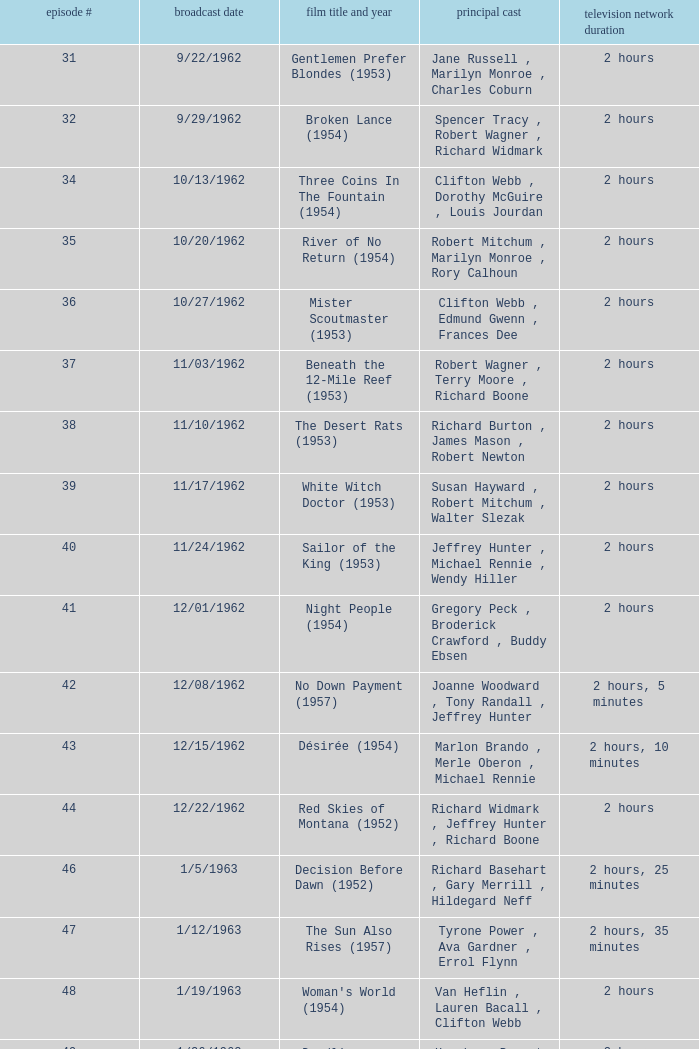Who was the cast on the 3/23/1963 episode? Dana Wynter , Mel Ferrer , Theodore Bikel. Could you parse the entire table? {'header': ['episode #', 'broadcast date', 'film title and year', 'principal cast', 'television network duration'], 'rows': [['31', '9/22/1962', 'Gentlemen Prefer Blondes (1953)', 'Jane Russell , Marilyn Monroe , Charles Coburn', '2 hours'], ['32', '9/29/1962', 'Broken Lance (1954)', 'Spencer Tracy , Robert Wagner , Richard Widmark', '2 hours'], ['34', '10/13/1962', 'Three Coins In The Fountain (1954)', 'Clifton Webb , Dorothy McGuire , Louis Jourdan', '2 hours'], ['35', '10/20/1962', 'River of No Return (1954)', 'Robert Mitchum , Marilyn Monroe , Rory Calhoun', '2 hours'], ['36', '10/27/1962', 'Mister Scoutmaster (1953)', 'Clifton Webb , Edmund Gwenn , Frances Dee', '2 hours'], ['37', '11/03/1962', 'Beneath the 12-Mile Reef (1953)', 'Robert Wagner , Terry Moore , Richard Boone', '2 hours'], ['38', '11/10/1962', 'The Desert Rats (1953)', 'Richard Burton , James Mason , Robert Newton', '2 hours'], ['39', '11/17/1962', 'White Witch Doctor (1953)', 'Susan Hayward , Robert Mitchum , Walter Slezak', '2 hours'], ['40', '11/24/1962', 'Sailor of the King (1953)', 'Jeffrey Hunter , Michael Rennie , Wendy Hiller', '2 hours'], ['41', '12/01/1962', 'Night People (1954)', 'Gregory Peck , Broderick Crawford , Buddy Ebsen', '2 hours'], ['42', '12/08/1962', 'No Down Payment (1957)', 'Joanne Woodward , Tony Randall , Jeffrey Hunter', '2 hours, 5 minutes'], ['43', '12/15/1962', 'Désirée (1954)', 'Marlon Brando , Merle Oberon , Michael Rennie', '2 hours, 10 minutes'], ['44', '12/22/1962', 'Red Skies of Montana (1952)', 'Richard Widmark , Jeffrey Hunter , Richard Boone', '2 hours'], ['46', '1/5/1963', 'Decision Before Dawn (1952)', 'Richard Basehart , Gary Merrill , Hildegard Neff', '2 hours, 25 minutes'], ['47', '1/12/1963', 'The Sun Also Rises (1957)', 'Tyrone Power , Ava Gardner , Errol Flynn', '2 hours, 35 minutes'], ['48', '1/19/1963', "Woman's World (1954)", 'Van Heflin , Lauren Bacall , Clifton Webb', '2 hours'], ['49', '1/26/1963', 'Deadline - U.S.A. (1952)', 'Humphrey Bogart , Kim Hunter , Ed Begley', '2 hours'], ['50', '2/2/1963', 'Niagara (1953)', 'Marilyn Monroe , Joseph Cotten , Jean Peters', '2 hours'], ['51', '2/9/1963', 'Kangaroo (1952)', "Maureen O'Hara , Peter Lawford , Richard Boone", '2 hours'], ['52', '2/16/1963', 'The Long Hot Summer (1958)', 'Paul Newman , Joanne Woodward , Orson Wells', '2 hours, 15 minutes'], ['53', '2/23/1963', "The President's Lady (1953)", 'Susan Hayward , Charlton Heston , John McIntire', '2 hours'], ['54', '3/2/1963', 'The Roots of Heaven (1958)', 'Errol Flynn , Juliette Greco , Eddie Albert', '2 hours, 25 minutes'], ['55', '3/9/1963', 'In Love and War (1958)', 'Robert Wagner , Hope Lange , Jeffrey Hunter', '2 hours, 10 minutes'], ['56', '3/16/1963', 'A Certain Smile (1958)', 'Rossano Brazzi , Joan Fontaine , Johnny Mathis', '2 hours, 5 minutes'], ['57', '3/23/1963', 'Fraulein (1958)', 'Dana Wynter , Mel Ferrer , Theodore Bikel', '2 hours'], ['59', '4/6/1963', 'Night and the City (1950)', 'Richard Widmark , Gene Tierney , Herbert Lom', '2 hours']]} 